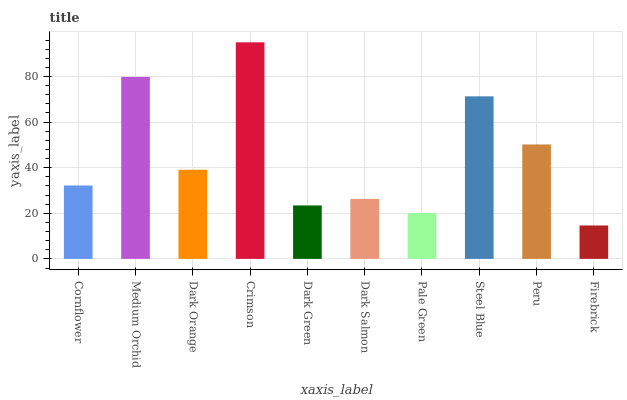Is Firebrick the minimum?
Answer yes or no. Yes. Is Crimson the maximum?
Answer yes or no. Yes. Is Medium Orchid the minimum?
Answer yes or no. No. Is Medium Orchid the maximum?
Answer yes or no. No. Is Medium Orchid greater than Cornflower?
Answer yes or no. Yes. Is Cornflower less than Medium Orchid?
Answer yes or no. Yes. Is Cornflower greater than Medium Orchid?
Answer yes or no. No. Is Medium Orchid less than Cornflower?
Answer yes or no. No. Is Dark Orange the high median?
Answer yes or no. Yes. Is Cornflower the low median?
Answer yes or no. Yes. Is Crimson the high median?
Answer yes or no. No. Is Crimson the low median?
Answer yes or no. No. 